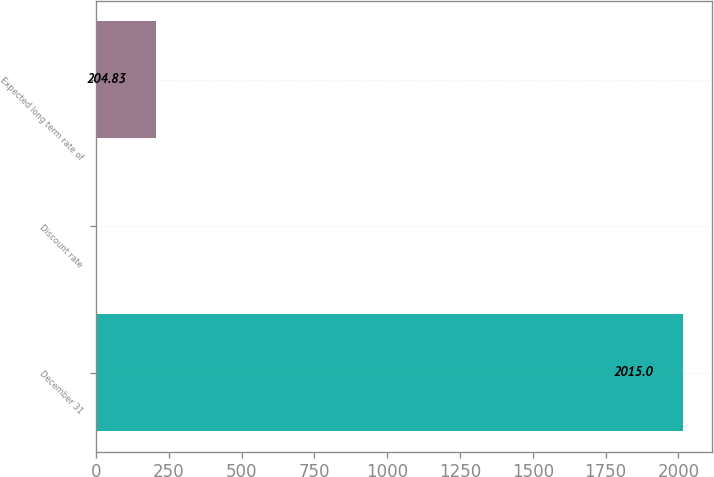<chart> <loc_0><loc_0><loc_500><loc_500><bar_chart><fcel>December 31<fcel>Discount rate<fcel>Expected long term rate of<nl><fcel>2015<fcel>3.7<fcel>204.83<nl></chart> 